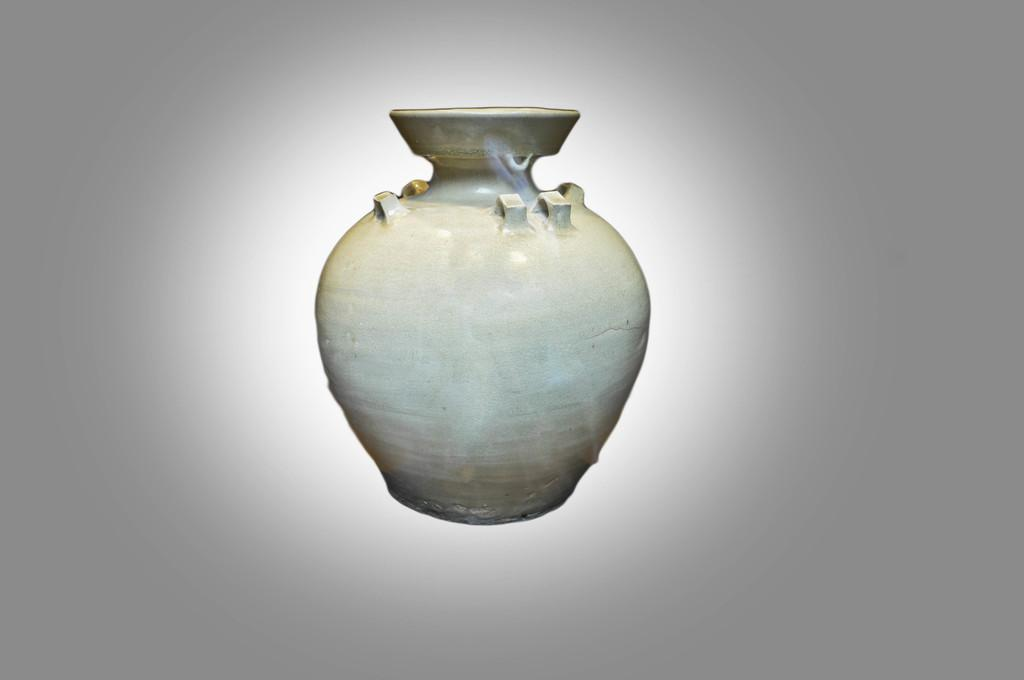What type of image is being described? The image is an edited picture. What is the main subject in the middle of the image? There is a pot in the middle of the image. What color is the background of the image? The background of the image is white. How many geese are visible in the wilderness in the image? There are no geese or wilderness present in the image; it features a pot on a white background. 